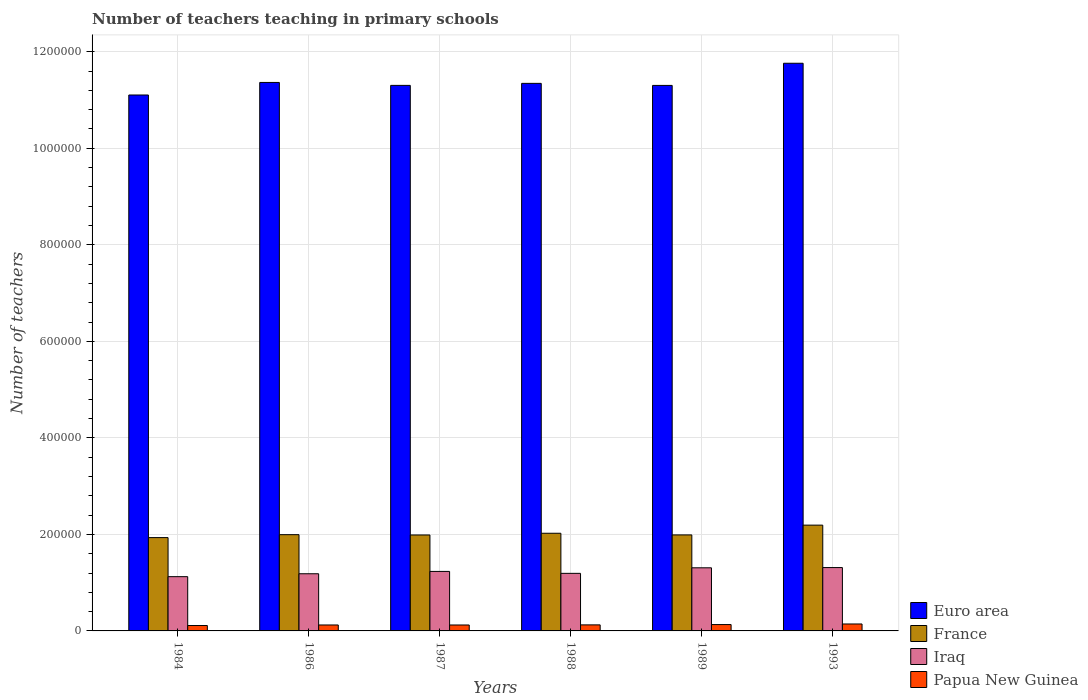How many groups of bars are there?
Make the answer very short. 6. What is the label of the 1st group of bars from the left?
Offer a very short reply. 1984. What is the number of teachers teaching in primary schools in Papua New Guinea in 1993?
Provide a short and direct response. 1.44e+04. Across all years, what is the maximum number of teachers teaching in primary schools in Iraq?
Make the answer very short. 1.31e+05. Across all years, what is the minimum number of teachers teaching in primary schools in France?
Ensure brevity in your answer.  1.93e+05. In which year was the number of teachers teaching in primary schools in Euro area maximum?
Provide a short and direct response. 1993. In which year was the number of teachers teaching in primary schools in Iraq minimum?
Make the answer very short. 1984. What is the total number of teachers teaching in primary schools in Papua New Guinea in the graph?
Provide a succinct answer. 7.59e+04. What is the difference between the number of teachers teaching in primary schools in Papua New Guinea in 1988 and that in 1993?
Your answer should be compact. -1851. What is the difference between the number of teachers teaching in primary schools in Iraq in 1993 and the number of teachers teaching in primary schools in Euro area in 1987?
Offer a very short reply. -9.99e+05. What is the average number of teachers teaching in primary schools in Papua New Guinea per year?
Ensure brevity in your answer.  1.26e+04. In the year 1993, what is the difference between the number of teachers teaching in primary schools in France and number of teachers teaching in primary schools in Euro area?
Give a very brief answer. -9.57e+05. In how many years, is the number of teachers teaching in primary schools in Iraq greater than 760000?
Make the answer very short. 0. What is the ratio of the number of teachers teaching in primary schools in Papua New Guinea in 1984 to that in 1988?
Offer a very short reply. 0.89. What is the difference between the highest and the second highest number of teachers teaching in primary schools in Iraq?
Offer a very short reply. 494. What is the difference between the highest and the lowest number of teachers teaching in primary schools in Euro area?
Your answer should be very brief. 6.58e+04. Is the sum of the number of teachers teaching in primary schools in France in 1984 and 1989 greater than the maximum number of teachers teaching in primary schools in Euro area across all years?
Your answer should be very brief. No. What does the 4th bar from the left in 1993 represents?
Make the answer very short. Papua New Guinea. What does the 2nd bar from the right in 1993 represents?
Ensure brevity in your answer.  Iraq. What is the difference between two consecutive major ticks on the Y-axis?
Offer a terse response. 2.00e+05. Does the graph contain any zero values?
Offer a terse response. No. Does the graph contain grids?
Your answer should be compact. Yes. Where does the legend appear in the graph?
Offer a very short reply. Bottom right. What is the title of the graph?
Ensure brevity in your answer.  Number of teachers teaching in primary schools. Does "Greece" appear as one of the legend labels in the graph?
Your answer should be compact. No. What is the label or title of the Y-axis?
Your answer should be compact. Number of teachers. What is the Number of teachers in Euro area in 1984?
Provide a short and direct response. 1.11e+06. What is the Number of teachers in France in 1984?
Provide a short and direct response. 1.93e+05. What is the Number of teachers of Iraq in 1984?
Your answer should be very brief. 1.12e+05. What is the Number of teachers of Papua New Guinea in 1984?
Provide a short and direct response. 1.12e+04. What is the Number of teachers in Euro area in 1986?
Make the answer very short. 1.14e+06. What is the Number of teachers in France in 1986?
Offer a very short reply. 1.99e+05. What is the Number of teachers in Iraq in 1986?
Give a very brief answer. 1.18e+05. What is the Number of teachers of Papua New Guinea in 1986?
Your answer should be compact. 1.23e+04. What is the Number of teachers in Euro area in 1987?
Your answer should be very brief. 1.13e+06. What is the Number of teachers in France in 1987?
Ensure brevity in your answer.  1.99e+05. What is the Number of teachers of Iraq in 1987?
Your answer should be very brief. 1.23e+05. What is the Number of teachers of Papua New Guinea in 1987?
Provide a succinct answer. 1.23e+04. What is the Number of teachers of Euro area in 1988?
Offer a very short reply. 1.13e+06. What is the Number of teachers in France in 1988?
Make the answer very short. 2.02e+05. What is the Number of teachers in Iraq in 1988?
Provide a short and direct response. 1.19e+05. What is the Number of teachers of Papua New Guinea in 1988?
Offer a terse response. 1.25e+04. What is the Number of teachers of Euro area in 1989?
Make the answer very short. 1.13e+06. What is the Number of teachers of France in 1989?
Your answer should be very brief. 1.99e+05. What is the Number of teachers of Iraq in 1989?
Offer a terse response. 1.31e+05. What is the Number of teachers of Papua New Guinea in 1989?
Your response must be concise. 1.32e+04. What is the Number of teachers in Euro area in 1993?
Make the answer very short. 1.18e+06. What is the Number of teachers of France in 1993?
Provide a short and direct response. 2.19e+05. What is the Number of teachers in Iraq in 1993?
Offer a very short reply. 1.31e+05. What is the Number of teachers of Papua New Guinea in 1993?
Provide a succinct answer. 1.44e+04. Across all years, what is the maximum Number of teachers in Euro area?
Your answer should be compact. 1.18e+06. Across all years, what is the maximum Number of teachers in France?
Provide a succinct answer. 2.19e+05. Across all years, what is the maximum Number of teachers in Iraq?
Make the answer very short. 1.31e+05. Across all years, what is the maximum Number of teachers of Papua New Guinea?
Your answer should be compact. 1.44e+04. Across all years, what is the minimum Number of teachers of Euro area?
Offer a very short reply. 1.11e+06. Across all years, what is the minimum Number of teachers of France?
Your response must be concise. 1.93e+05. Across all years, what is the minimum Number of teachers in Iraq?
Your answer should be very brief. 1.12e+05. Across all years, what is the minimum Number of teachers of Papua New Guinea?
Your answer should be very brief. 1.12e+04. What is the total Number of teachers in Euro area in the graph?
Your answer should be compact. 6.82e+06. What is the total Number of teachers in France in the graph?
Your answer should be very brief. 1.21e+06. What is the total Number of teachers in Iraq in the graph?
Provide a succinct answer. 7.36e+05. What is the total Number of teachers in Papua New Guinea in the graph?
Offer a very short reply. 7.59e+04. What is the difference between the Number of teachers of Euro area in 1984 and that in 1986?
Provide a succinct answer. -2.60e+04. What is the difference between the Number of teachers in France in 1984 and that in 1986?
Your answer should be very brief. -6092. What is the difference between the Number of teachers in Iraq in 1984 and that in 1986?
Your answer should be compact. -6014. What is the difference between the Number of teachers of Papua New Guinea in 1984 and that in 1986?
Your answer should be compact. -1134. What is the difference between the Number of teachers in Euro area in 1984 and that in 1987?
Your response must be concise. -1.99e+04. What is the difference between the Number of teachers of France in 1984 and that in 1987?
Give a very brief answer. -5447. What is the difference between the Number of teachers of Iraq in 1984 and that in 1987?
Keep it short and to the point. -1.09e+04. What is the difference between the Number of teachers of Papua New Guinea in 1984 and that in 1987?
Ensure brevity in your answer.  -1110. What is the difference between the Number of teachers of Euro area in 1984 and that in 1988?
Provide a succinct answer. -2.41e+04. What is the difference between the Number of teachers of France in 1984 and that in 1988?
Keep it short and to the point. -8995. What is the difference between the Number of teachers of Iraq in 1984 and that in 1988?
Make the answer very short. -6852. What is the difference between the Number of teachers in Papua New Guinea in 1984 and that in 1988?
Provide a short and direct response. -1343. What is the difference between the Number of teachers in Euro area in 1984 and that in 1989?
Offer a very short reply. -1.99e+04. What is the difference between the Number of teachers in France in 1984 and that in 1989?
Provide a short and direct response. -5569. What is the difference between the Number of teachers of Iraq in 1984 and that in 1989?
Offer a very short reply. -1.83e+04. What is the difference between the Number of teachers in Papua New Guinea in 1984 and that in 1989?
Give a very brief answer. -1987. What is the difference between the Number of teachers in Euro area in 1984 and that in 1993?
Provide a short and direct response. -6.58e+04. What is the difference between the Number of teachers in France in 1984 and that in 1993?
Provide a short and direct response. -2.58e+04. What is the difference between the Number of teachers in Iraq in 1984 and that in 1993?
Provide a succinct answer. -1.88e+04. What is the difference between the Number of teachers in Papua New Guinea in 1984 and that in 1993?
Keep it short and to the point. -3194. What is the difference between the Number of teachers of Euro area in 1986 and that in 1987?
Give a very brief answer. 6095.5. What is the difference between the Number of teachers in France in 1986 and that in 1987?
Provide a succinct answer. 645. What is the difference between the Number of teachers of Iraq in 1986 and that in 1987?
Give a very brief answer. -4868. What is the difference between the Number of teachers of Euro area in 1986 and that in 1988?
Provide a short and direct response. 1908.38. What is the difference between the Number of teachers of France in 1986 and that in 1988?
Make the answer very short. -2903. What is the difference between the Number of teachers in Iraq in 1986 and that in 1988?
Your answer should be compact. -838. What is the difference between the Number of teachers of Papua New Guinea in 1986 and that in 1988?
Keep it short and to the point. -209. What is the difference between the Number of teachers in Euro area in 1986 and that in 1989?
Provide a succinct answer. 6147.88. What is the difference between the Number of teachers in France in 1986 and that in 1989?
Your response must be concise. 523. What is the difference between the Number of teachers of Iraq in 1986 and that in 1989?
Your answer should be very brief. -1.23e+04. What is the difference between the Number of teachers in Papua New Guinea in 1986 and that in 1989?
Give a very brief answer. -853. What is the difference between the Number of teachers of Euro area in 1986 and that in 1993?
Provide a short and direct response. -3.97e+04. What is the difference between the Number of teachers in France in 1986 and that in 1993?
Your answer should be very brief. -1.97e+04. What is the difference between the Number of teachers in Iraq in 1986 and that in 1993?
Your answer should be compact. -1.28e+04. What is the difference between the Number of teachers of Papua New Guinea in 1986 and that in 1993?
Give a very brief answer. -2060. What is the difference between the Number of teachers of Euro area in 1987 and that in 1988?
Provide a short and direct response. -4187.12. What is the difference between the Number of teachers in France in 1987 and that in 1988?
Provide a short and direct response. -3548. What is the difference between the Number of teachers in Iraq in 1987 and that in 1988?
Give a very brief answer. 4030. What is the difference between the Number of teachers in Papua New Guinea in 1987 and that in 1988?
Give a very brief answer. -233. What is the difference between the Number of teachers of Euro area in 1987 and that in 1989?
Give a very brief answer. 52.38. What is the difference between the Number of teachers of France in 1987 and that in 1989?
Keep it short and to the point. -122. What is the difference between the Number of teachers of Iraq in 1987 and that in 1989?
Your response must be concise. -7467. What is the difference between the Number of teachers of Papua New Guinea in 1987 and that in 1989?
Offer a terse response. -877. What is the difference between the Number of teachers in Euro area in 1987 and that in 1993?
Your response must be concise. -4.58e+04. What is the difference between the Number of teachers in France in 1987 and that in 1993?
Keep it short and to the point. -2.04e+04. What is the difference between the Number of teachers in Iraq in 1987 and that in 1993?
Ensure brevity in your answer.  -7961. What is the difference between the Number of teachers in Papua New Guinea in 1987 and that in 1993?
Your response must be concise. -2084. What is the difference between the Number of teachers in Euro area in 1988 and that in 1989?
Your answer should be compact. 4239.5. What is the difference between the Number of teachers of France in 1988 and that in 1989?
Your answer should be very brief. 3426. What is the difference between the Number of teachers in Iraq in 1988 and that in 1989?
Keep it short and to the point. -1.15e+04. What is the difference between the Number of teachers of Papua New Guinea in 1988 and that in 1989?
Provide a succinct answer. -644. What is the difference between the Number of teachers of Euro area in 1988 and that in 1993?
Your answer should be very brief. -4.17e+04. What is the difference between the Number of teachers in France in 1988 and that in 1993?
Keep it short and to the point. -1.68e+04. What is the difference between the Number of teachers in Iraq in 1988 and that in 1993?
Your response must be concise. -1.20e+04. What is the difference between the Number of teachers in Papua New Guinea in 1988 and that in 1993?
Your answer should be compact. -1851. What is the difference between the Number of teachers in Euro area in 1989 and that in 1993?
Ensure brevity in your answer.  -4.59e+04. What is the difference between the Number of teachers of France in 1989 and that in 1993?
Your answer should be compact. -2.03e+04. What is the difference between the Number of teachers in Iraq in 1989 and that in 1993?
Make the answer very short. -494. What is the difference between the Number of teachers in Papua New Guinea in 1989 and that in 1993?
Your response must be concise. -1207. What is the difference between the Number of teachers of Euro area in 1984 and the Number of teachers of France in 1986?
Your answer should be compact. 9.11e+05. What is the difference between the Number of teachers in Euro area in 1984 and the Number of teachers in Iraq in 1986?
Ensure brevity in your answer.  9.92e+05. What is the difference between the Number of teachers of Euro area in 1984 and the Number of teachers of Papua New Guinea in 1986?
Ensure brevity in your answer.  1.10e+06. What is the difference between the Number of teachers in France in 1984 and the Number of teachers in Iraq in 1986?
Offer a terse response. 7.49e+04. What is the difference between the Number of teachers in France in 1984 and the Number of teachers in Papua New Guinea in 1986?
Keep it short and to the point. 1.81e+05. What is the difference between the Number of teachers in Iraq in 1984 and the Number of teachers in Papua New Guinea in 1986?
Provide a short and direct response. 1.00e+05. What is the difference between the Number of teachers of Euro area in 1984 and the Number of teachers of France in 1987?
Give a very brief answer. 9.12e+05. What is the difference between the Number of teachers in Euro area in 1984 and the Number of teachers in Iraq in 1987?
Your answer should be compact. 9.87e+05. What is the difference between the Number of teachers in Euro area in 1984 and the Number of teachers in Papua New Guinea in 1987?
Your answer should be very brief. 1.10e+06. What is the difference between the Number of teachers of France in 1984 and the Number of teachers of Iraq in 1987?
Your response must be concise. 7.00e+04. What is the difference between the Number of teachers in France in 1984 and the Number of teachers in Papua New Guinea in 1987?
Offer a terse response. 1.81e+05. What is the difference between the Number of teachers in Iraq in 1984 and the Number of teachers in Papua New Guinea in 1987?
Your answer should be compact. 1.00e+05. What is the difference between the Number of teachers of Euro area in 1984 and the Number of teachers of France in 1988?
Keep it short and to the point. 9.08e+05. What is the difference between the Number of teachers of Euro area in 1984 and the Number of teachers of Iraq in 1988?
Your answer should be very brief. 9.91e+05. What is the difference between the Number of teachers in Euro area in 1984 and the Number of teachers in Papua New Guinea in 1988?
Make the answer very short. 1.10e+06. What is the difference between the Number of teachers in France in 1984 and the Number of teachers in Iraq in 1988?
Offer a very short reply. 7.41e+04. What is the difference between the Number of teachers of France in 1984 and the Number of teachers of Papua New Guinea in 1988?
Make the answer very short. 1.81e+05. What is the difference between the Number of teachers of Iraq in 1984 and the Number of teachers of Papua New Guinea in 1988?
Make the answer very short. 9.99e+04. What is the difference between the Number of teachers of Euro area in 1984 and the Number of teachers of France in 1989?
Your response must be concise. 9.12e+05. What is the difference between the Number of teachers of Euro area in 1984 and the Number of teachers of Iraq in 1989?
Provide a succinct answer. 9.80e+05. What is the difference between the Number of teachers of Euro area in 1984 and the Number of teachers of Papua New Guinea in 1989?
Keep it short and to the point. 1.10e+06. What is the difference between the Number of teachers of France in 1984 and the Number of teachers of Iraq in 1989?
Your response must be concise. 6.26e+04. What is the difference between the Number of teachers of France in 1984 and the Number of teachers of Papua New Guinea in 1989?
Offer a very short reply. 1.80e+05. What is the difference between the Number of teachers of Iraq in 1984 and the Number of teachers of Papua New Guinea in 1989?
Offer a very short reply. 9.93e+04. What is the difference between the Number of teachers of Euro area in 1984 and the Number of teachers of France in 1993?
Give a very brief answer. 8.91e+05. What is the difference between the Number of teachers in Euro area in 1984 and the Number of teachers in Iraq in 1993?
Make the answer very short. 9.79e+05. What is the difference between the Number of teachers of Euro area in 1984 and the Number of teachers of Papua New Guinea in 1993?
Provide a succinct answer. 1.10e+06. What is the difference between the Number of teachers of France in 1984 and the Number of teachers of Iraq in 1993?
Your response must be concise. 6.21e+04. What is the difference between the Number of teachers in France in 1984 and the Number of teachers in Papua New Guinea in 1993?
Provide a succinct answer. 1.79e+05. What is the difference between the Number of teachers of Iraq in 1984 and the Number of teachers of Papua New Guinea in 1993?
Give a very brief answer. 9.80e+04. What is the difference between the Number of teachers in Euro area in 1986 and the Number of teachers in France in 1987?
Your response must be concise. 9.38e+05. What is the difference between the Number of teachers of Euro area in 1986 and the Number of teachers of Iraq in 1987?
Your answer should be very brief. 1.01e+06. What is the difference between the Number of teachers in Euro area in 1986 and the Number of teachers in Papua New Guinea in 1987?
Give a very brief answer. 1.12e+06. What is the difference between the Number of teachers of France in 1986 and the Number of teachers of Iraq in 1987?
Provide a succinct answer. 7.61e+04. What is the difference between the Number of teachers of France in 1986 and the Number of teachers of Papua New Guinea in 1987?
Give a very brief answer. 1.87e+05. What is the difference between the Number of teachers in Iraq in 1986 and the Number of teachers in Papua New Guinea in 1987?
Provide a succinct answer. 1.06e+05. What is the difference between the Number of teachers of Euro area in 1986 and the Number of teachers of France in 1988?
Your answer should be compact. 9.34e+05. What is the difference between the Number of teachers in Euro area in 1986 and the Number of teachers in Iraq in 1988?
Offer a terse response. 1.02e+06. What is the difference between the Number of teachers of Euro area in 1986 and the Number of teachers of Papua New Guinea in 1988?
Ensure brevity in your answer.  1.12e+06. What is the difference between the Number of teachers in France in 1986 and the Number of teachers in Iraq in 1988?
Provide a short and direct response. 8.02e+04. What is the difference between the Number of teachers in France in 1986 and the Number of teachers in Papua New Guinea in 1988?
Give a very brief answer. 1.87e+05. What is the difference between the Number of teachers in Iraq in 1986 and the Number of teachers in Papua New Guinea in 1988?
Your answer should be very brief. 1.06e+05. What is the difference between the Number of teachers of Euro area in 1986 and the Number of teachers of France in 1989?
Your answer should be compact. 9.38e+05. What is the difference between the Number of teachers in Euro area in 1986 and the Number of teachers in Iraq in 1989?
Offer a terse response. 1.01e+06. What is the difference between the Number of teachers in Euro area in 1986 and the Number of teachers in Papua New Guinea in 1989?
Your answer should be compact. 1.12e+06. What is the difference between the Number of teachers in France in 1986 and the Number of teachers in Iraq in 1989?
Provide a succinct answer. 6.87e+04. What is the difference between the Number of teachers of France in 1986 and the Number of teachers of Papua New Guinea in 1989?
Offer a terse response. 1.86e+05. What is the difference between the Number of teachers of Iraq in 1986 and the Number of teachers of Papua New Guinea in 1989?
Your response must be concise. 1.05e+05. What is the difference between the Number of teachers of Euro area in 1986 and the Number of teachers of France in 1993?
Provide a short and direct response. 9.17e+05. What is the difference between the Number of teachers of Euro area in 1986 and the Number of teachers of Iraq in 1993?
Ensure brevity in your answer.  1.01e+06. What is the difference between the Number of teachers in Euro area in 1986 and the Number of teachers in Papua New Guinea in 1993?
Your answer should be very brief. 1.12e+06. What is the difference between the Number of teachers in France in 1986 and the Number of teachers in Iraq in 1993?
Provide a short and direct response. 6.82e+04. What is the difference between the Number of teachers of France in 1986 and the Number of teachers of Papua New Guinea in 1993?
Give a very brief answer. 1.85e+05. What is the difference between the Number of teachers of Iraq in 1986 and the Number of teachers of Papua New Guinea in 1993?
Give a very brief answer. 1.04e+05. What is the difference between the Number of teachers in Euro area in 1987 and the Number of teachers in France in 1988?
Ensure brevity in your answer.  9.28e+05. What is the difference between the Number of teachers in Euro area in 1987 and the Number of teachers in Iraq in 1988?
Offer a terse response. 1.01e+06. What is the difference between the Number of teachers in Euro area in 1987 and the Number of teachers in Papua New Guinea in 1988?
Your response must be concise. 1.12e+06. What is the difference between the Number of teachers of France in 1987 and the Number of teachers of Iraq in 1988?
Make the answer very short. 7.95e+04. What is the difference between the Number of teachers of France in 1987 and the Number of teachers of Papua New Guinea in 1988?
Keep it short and to the point. 1.86e+05. What is the difference between the Number of teachers in Iraq in 1987 and the Number of teachers in Papua New Guinea in 1988?
Make the answer very short. 1.11e+05. What is the difference between the Number of teachers of Euro area in 1987 and the Number of teachers of France in 1989?
Provide a short and direct response. 9.31e+05. What is the difference between the Number of teachers of Euro area in 1987 and the Number of teachers of Iraq in 1989?
Provide a succinct answer. 1.00e+06. What is the difference between the Number of teachers in Euro area in 1987 and the Number of teachers in Papua New Guinea in 1989?
Ensure brevity in your answer.  1.12e+06. What is the difference between the Number of teachers of France in 1987 and the Number of teachers of Iraq in 1989?
Offer a terse response. 6.80e+04. What is the difference between the Number of teachers in France in 1987 and the Number of teachers in Papua New Guinea in 1989?
Give a very brief answer. 1.86e+05. What is the difference between the Number of teachers in Iraq in 1987 and the Number of teachers in Papua New Guinea in 1989?
Your answer should be very brief. 1.10e+05. What is the difference between the Number of teachers in Euro area in 1987 and the Number of teachers in France in 1993?
Give a very brief answer. 9.11e+05. What is the difference between the Number of teachers in Euro area in 1987 and the Number of teachers in Iraq in 1993?
Offer a very short reply. 9.99e+05. What is the difference between the Number of teachers in Euro area in 1987 and the Number of teachers in Papua New Guinea in 1993?
Offer a terse response. 1.12e+06. What is the difference between the Number of teachers of France in 1987 and the Number of teachers of Iraq in 1993?
Provide a succinct answer. 6.75e+04. What is the difference between the Number of teachers in France in 1987 and the Number of teachers in Papua New Guinea in 1993?
Ensure brevity in your answer.  1.84e+05. What is the difference between the Number of teachers of Iraq in 1987 and the Number of teachers of Papua New Guinea in 1993?
Your response must be concise. 1.09e+05. What is the difference between the Number of teachers of Euro area in 1988 and the Number of teachers of France in 1989?
Give a very brief answer. 9.36e+05. What is the difference between the Number of teachers in Euro area in 1988 and the Number of teachers in Iraq in 1989?
Make the answer very short. 1.00e+06. What is the difference between the Number of teachers of Euro area in 1988 and the Number of teachers of Papua New Guinea in 1989?
Make the answer very short. 1.12e+06. What is the difference between the Number of teachers of France in 1988 and the Number of teachers of Iraq in 1989?
Provide a short and direct response. 7.16e+04. What is the difference between the Number of teachers of France in 1988 and the Number of teachers of Papua New Guinea in 1989?
Offer a terse response. 1.89e+05. What is the difference between the Number of teachers of Iraq in 1988 and the Number of teachers of Papua New Guinea in 1989?
Provide a short and direct response. 1.06e+05. What is the difference between the Number of teachers of Euro area in 1988 and the Number of teachers of France in 1993?
Make the answer very short. 9.15e+05. What is the difference between the Number of teachers of Euro area in 1988 and the Number of teachers of Iraq in 1993?
Keep it short and to the point. 1.00e+06. What is the difference between the Number of teachers in Euro area in 1988 and the Number of teachers in Papua New Guinea in 1993?
Provide a succinct answer. 1.12e+06. What is the difference between the Number of teachers of France in 1988 and the Number of teachers of Iraq in 1993?
Offer a terse response. 7.11e+04. What is the difference between the Number of teachers in France in 1988 and the Number of teachers in Papua New Guinea in 1993?
Your answer should be compact. 1.88e+05. What is the difference between the Number of teachers in Iraq in 1988 and the Number of teachers in Papua New Guinea in 1993?
Your answer should be very brief. 1.05e+05. What is the difference between the Number of teachers in Euro area in 1989 and the Number of teachers in France in 1993?
Provide a short and direct response. 9.11e+05. What is the difference between the Number of teachers of Euro area in 1989 and the Number of teachers of Iraq in 1993?
Ensure brevity in your answer.  9.99e+05. What is the difference between the Number of teachers of Euro area in 1989 and the Number of teachers of Papua New Guinea in 1993?
Provide a short and direct response. 1.12e+06. What is the difference between the Number of teachers in France in 1989 and the Number of teachers in Iraq in 1993?
Provide a short and direct response. 6.77e+04. What is the difference between the Number of teachers of France in 1989 and the Number of teachers of Papua New Guinea in 1993?
Give a very brief answer. 1.85e+05. What is the difference between the Number of teachers of Iraq in 1989 and the Number of teachers of Papua New Guinea in 1993?
Ensure brevity in your answer.  1.16e+05. What is the average Number of teachers in Euro area per year?
Your response must be concise. 1.14e+06. What is the average Number of teachers in France per year?
Provide a short and direct response. 2.02e+05. What is the average Number of teachers of Iraq per year?
Give a very brief answer. 1.23e+05. What is the average Number of teachers in Papua New Guinea per year?
Keep it short and to the point. 1.26e+04. In the year 1984, what is the difference between the Number of teachers in Euro area and Number of teachers in France?
Provide a succinct answer. 9.17e+05. In the year 1984, what is the difference between the Number of teachers in Euro area and Number of teachers in Iraq?
Keep it short and to the point. 9.98e+05. In the year 1984, what is the difference between the Number of teachers in Euro area and Number of teachers in Papua New Guinea?
Make the answer very short. 1.10e+06. In the year 1984, what is the difference between the Number of teachers in France and Number of teachers in Iraq?
Offer a very short reply. 8.09e+04. In the year 1984, what is the difference between the Number of teachers in France and Number of teachers in Papua New Guinea?
Offer a terse response. 1.82e+05. In the year 1984, what is the difference between the Number of teachers of Iraq and Number of teachers of Papua New Guinea?
Provide a short and direct response. 1.01e+05. In the year 1986, what is the difference between the Number of teachers in Euro area and Number of teachers in France?
Make the answer very short. 9.37e+05. In the year 1986, what is the difference between the Number of teachers in Euro area and Number of teachers in Iraq?
Make the answer very short. 1.02e+06. In the year 1986, what is the difference between the Number of teachers in Euro area and Number of teachers in Papua New Guinea?
Offer a very short reply. 1.12e+06. In the year 1986, what is the difference between the Number of teachers in France and Number of teachers in Iraq?
Offer a very short reply. 8.10e+04. In the year 1986, what is the difference between the Number of teachers of France and Number of teachers of Papua New Guinea?
Give a very brief answer. 1.87e+05. In the year 1986, what is the difference between the Number of teachers of Iraq and Number of teachers of Papua New Guinea?
Offer a very short reply. 1.06e+05. In the year 1987, what is the difference between the Number of teachers in Euro area and Number of teachers in France?
Your answer should be compact. 9.32e+05. In the year 1987, what is the difference between the Number of teachers in Euro area and Number of teachers in Iraq?
Offer a terse response. 1.01e+06. In the year 1987, what is the difference between the Number of teachers of Euro area and Number of teachers of Papua New Guinea?
Give a very brief answer. 1.12e+06. In the year 1987, what is the difference between the Number of teachers of France and Number of teachers of Iraq?
Give a very brief answer. 7.55e+04. In the year 1987, what is the difference between the Number of teachers in France and Number of teachers in Papua New Guinea?
Your answer should be compact. 1.87e+05. In the year 1987, what is the difference between the Number of teachers in Iraq and Number of teachers in Papua New Guinea?
Ensure brevity in your answer.  1.11e+05. In the year 1988, what is the difference between the Number of teachers of Euro area and Number of teachers of France?
Ensure brevity in your answer.  9.32e+05. In the year 1988, what is the difference between the Number of teachers of Euro area and Number of teachers of Iraq?
Provide a short and direct response. 1.02e+06. In the year 1988, what is the difference between the Number of teachers of Euro area and Number of teachers of Papua New Guinea?
Keep it short and to the point. 1.12e+06. In the year 1988, what is the difference between the Number of teachers of France and Number of teachers of Iraq?
Your answer should be compact. 8.31e+04. In the year 1988, what is the difference between the Number of teachers of France and Number of teachers of Papua New Guinea?
Your answer should be very brief. 1.90e+05. In the year 1988, what is the difference between the Number of teachers of Iraq and Number of teachers of Papua New Guinea?
Your answer should be very brief. 1.07e+05. In the year 1989, what is the difference between the Number of teachers of Euro area and Number of teachers of France?
Your answer should be compact. 9.31e+05. In the year 1989, what is the difference between the Number of teachers in Euro area and Number of teachers in Iraq?
Ensure brevity in your answer.  1.00e+06. In the year 1989, what is the difference between the Number of teachers of Euro area and Number of teachers of Papua New Guinea?
Offer a very short reply. 1.12e+06. In the year 1989, what is the difference between the Number of teachers in France and Number of teachers in Iraq?
Make the answer very short. 6.81e+04. In the year 1989, what is the difference between the Number of teachers in France and Number of teachers in Papua New Guinea?
Provide a succinct answer. 1.86e+05. In the year 1989, what is the difference between the Number of teachers in Iraq and Number of teachers in Papua New Guinea?
Provide a succinct answer. 1.18e+05. In the year 1993, what is the difference between the Number of teachers of Euro area and Number of teachers of France?
Your response must be concise. 9.57e+05. In the year 1993, what is the difference between the Number of teachers in Euro area and Number of teachers in Iraq?
Give a very brief answer. 1.04e+06. In the year 1993, what is the difference between the Number of teachers of Euro area and Number of teachers of Papua New Guinea?
Your answer should be very brief. 1.16e+06. In the year 1993, what is the difference between the Number of teachers in France and Number of teachers in Iraq?
Offer a very short reply. 8.79e+04. In the year 1993, what is the difference between the Number of teachers in France and Number of teachers in Papua New Guinea?
Keep it short and to the point. 2.05e+05. In the year 1993, what is the difference between the Number of teachers of Iraq and Number of teachers of Papua New Guinea?
Your answer should be compact. 1.17e+05. What is the ratio of the Number of teachers of Euro area in 1984 to that in 1986?
Your answer should be very brief. 0.98. What is the ratio of the Number of teachers in France in 1984 to that in 1986?
Your response must be concise. 0.97. What is the ratio of the Number of teachers in Iraq in 1984 to that in 1986?
Give a very brief answer. 0.95. What is the ratio of the Number of teachers in Papua New Guinea in 1984 to that in 1986?
Give a very brief answer. 0.91. What is the ratio of the Number of teachers of Euro area in 1984 to that in 1987?
Make the answer very short. 0.98. What is the ratio of the Number of teachers in France in 1984 to that in 1987?
Offer a terse response. 0.97. What is the ratio of the Number of teachers in Iraq in 1984 to that in 1987?
Provide a succinct answer. 0.91. What is the ratio of the Number of teachers in Papua New Guinea in 1984 to that in 1987?
Provide a succinct answer. 0.91. What is the ratio of the Number of teachers in Euro area in 1984 to that in 1988?
Your response must be concise. 0.98. What is the ratio of the Number of teachers of France in 1984 to that in 1988?
Offer a very short reply. 0.96. What is the ratio of the Number of teachers in Iraq in 1984 to that in 1988?
Give a very brief answer. 0.94. What is the ratio of the Number of teachers of Papua New Guinea in 1984 to that in 1988?
Ensure brevity in your answer.  0.89. What is the ratio of the Number of teachers in Euro area in 1984 to that in 1989?
Give a very brief answer. 0.98. What is the ratio of the Number of teachers in France in 1984 to that in 1989?
Your answer should be compact. 0.97. What is the ratio of the Number of teachers of Iraq in 1984 to that in 1989?
Provide a short and direct response. 0.86. What is the ratio of the Number of teachers of Papua New Guinea in 1984 to that in 1989?
Your answer should be very brief. 0.85. What is the ratio of the Number of teachers of Euro area in 1984 to that in 1993?
Your answer should be compact. 0.94. What is the ratio of the Number of teachers of France in 1984 to that in 1993?
Keep it short and to the point. 0.88. What is the ratio of the Number of teachers of Iraq in 1984 to that in 1993?
Offer a terse response. 0.86. What is the ratio of the Number of teachers of Papua New Guinea in 1984 to that in 1993?
Your answer should be very brief. 0.78. What is the ratio of the Number of teachers of Euro area in 1986 to that in 1987?
Your response must be concise. 1.01. What is the ratio of the Number of teachers in France in 1986 to that in 1987?
Make the answer very short. 1. What is the ratio of the Number of teachers in Iraq in 1986 to that in 1987?
Your answer should be compact. 0.96. What is the ratio of the Number of teachers in France in 1986 to that in 1988?
Ensure brevity in your answer.  0.99. What is the ratio of the Number of teachers in Iraq in 1986 to that in 1988?
Your answer should be compact. 0.99. What is the ratio of the Number of teachers in Papua New Guinea in 1986 to that in 1988?
Make the answer very short. 0.98. What is the ratio of the Number of teachers in Euro area in 1986 to that in 1989?
Your answer should be compact. 1.01. What is the ratio of the Number of teachers of Iraq in 1986 to that in 1989?
Your response must be concise. 0.91. What is the ratio of the Number of teachers in Papua New Guinea in 1986 to that in 1989?
Provide a short and direct response. 0.94. What is the ratio of the Number of teachers in Euro area in 1986 to that in 1993?
Provide a succinct answer. 0.97. What is the ratio of the Number of teachers of France in 1986 to that in 1993?
Give a very brief answer. 0.91. What is the ratio of the Number of teachers of Iraq in 1986 to that in 1993?
Provide a short and direct response. 0.9. What is the ratio of the Number of teachers in Papua New Guinea in 1986 to that in 1993?
Provide a succinct answer. 0.86. What is the ratio of the Number of teachers of Euro area in 1987 to that in 1988?
Ensure brevity in your answer.  1. What is the ratio of the Number of teachers of France in 1987 to that in 1988?
Give a very brief answer. 0.98. What is the ratio of the Number of teachers of Iraq in 1987 to that in 1988?
Ensure brevity in your answer.  1.03. What is the ratio of the Number of teachers of Papua New Guinea in 1987 to that in 1988?
Your answer should be very brief. 0.98. What is the ratio of the Number of teachers in Euro area in 1987 to that in 1989?
Offer a very short reply. 1. What is the ratio of the Number of teachers of Iraq in 1987 to that in 1989?
Make the answer very short. 0.94. What is the ratio of the Number of teachers in Papua New Guinea in 1987 to that in 1989?
Make the answer very short. 0.93. What is the ratio of the Number of teachers of France in 1987 to that in 1993?
Keep it short and to the point. 0.91. What is the ratio of the Number of teachers of Iraq in 1987 to that in 1993?
Give a very brief answer. 0.94. What is the ratio of the Number of teachers of Papua New Guinea in 1987 to that in 1993?
Your response must be concise. 0.86. What is the ratio of the Number of teachers of France in 1988 to that in 1989?
Your answer should be very brief. 1.02. What is the ratio of the Number of teachers in Iraq in 1988 to that in 1989?
Your response must be concise. 0.91. What is the ratio of the Number of teachers in Papua New Guinea in 1988 to that in 1989?
Make the answer very short. 0.95. What is the ratio of the Number of teachers of Euro area in 1988 to that in 1993?
Your response must be concise. 0.96. What is the ratio of the Number of teachers in France in 1988 to that in 1993?
Keep it short and to the point. 0.92. What is the ratio of the Number of teachers of Iraq in 1988 to that in 1993?
Your answer should be very brief. 0.91. What is the ratio of the Number of teachers of Papua New Guinea in 1988 to that in 1993?
Offer a very short reply. 0.87. What is the ratio of the Number of teachers of France in 1989 to that in 1993?
Offer a terse response. 0.91. What is the ratio of the Number of teachers of Papua New Guinea in 1989 to that in 1993?
Your answer should be compact. 0.92. What is the difference between the highest and the second highest Number of teachers in Euro area?
Your answer should be very brief. 3.97e+04. What is the difference between the highest and the second highest Number of teachers in France?
Your answer should be very brief. 1.68e+04. What is the difference between the highest and the second highest Number of teachers of Iraq?
Keep it short and to the point. 494. What is the difference between the highest and the second highest Number of teachers in Papua New Guinea?
Give a very brief answer. 1207. What is the difference between the highest and the lowest Number of teachers of Euro area?
Keep it short and to the point. 6.58e+04. What is the difference between the highest and the lowest Number of teachers in France?
Provide a succinct answer. 2.58e+04. What is the difference between the highest and the lowest Number of teachers of Iraq?
Provide a succinct answer. 1.88e+04. What is the difference between the highest and the lowest Number of teachers of Papua New Guinea?
Ensure brevity in your answer.  3194. 